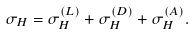<formula> <loc_0><loc_0><loc_500><loc_500>\sigma _ { H } = \sigma _ { H } ^ { ( L ) } + \sigma _ { H } ^ { ( D ) } + \sigma _ { H } ^ { ( A ) } .</formula> 